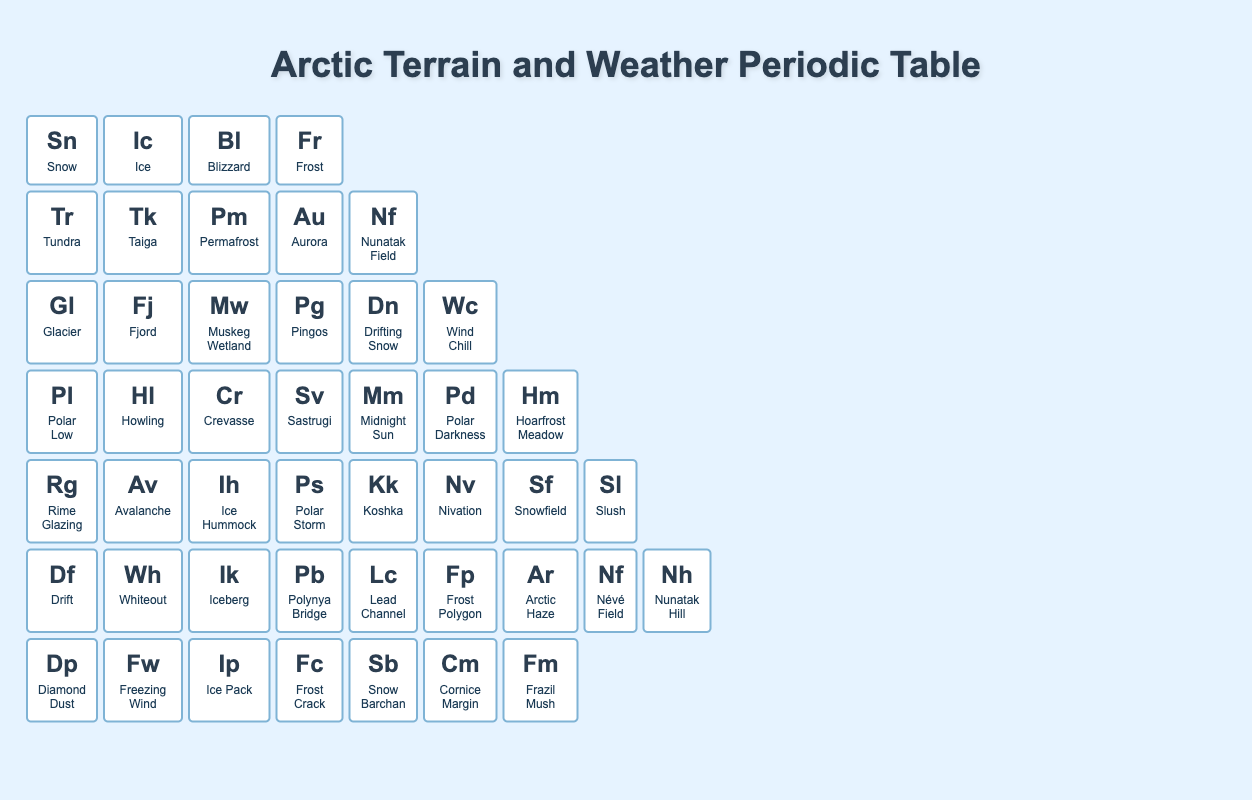What is the symbol for Tundra? The symbol for Tundra can be found by locating the element in the table; Tundra is listed under group 1 and period 2, and its symbol is Tr.
Answer: Tr How many elements are in period 3? To find the number of elements in period 3, count the entries listed in that row of the table; there are 6 elements: Glacier, Fjord, Muskeg Wetland, Pingos, Drifting Snow, and Wind Chill.
Answer: 6 Is Ice in group 2? By identifying the group of Ice in the table, we see it is listed under group 2. Therefore, the statement is true.
Answer: Yes Which element has the highest period number? The element with the highest period number is the last row of the table, which corresponds to period 7. The elements listed there are Diamond Dust, Freezing Wind, Ice Pack, Frost Crack, Snow Barchan, Cornice Margin, and Frazil Mush; hence, all of these belong to period 7.
Answer: Diamond Dust, Freezing Wind, Ice Pack, Frost Crack, Snow Barchan, Cornice Margin, Frazil Mush How many unique groups are represented in period 5? We can find the elements in period 5: Rime Glazing, Avalanche, Ice Hummock, Polar Storm, Koshka, Nivation, Snowfield, and Slush. Their groups are 1, 2, 3, 4, 5, 6, 7, and 8—a total of 8 unique groups are present.
Answer: 8 What is the total count of elements from group 3? Observe the elements listed in group 3 across all periods. The elements are Blizzard, Permafrost, Muskeg Wetland, Crevasse, Ice Hummock, and Ice Pack, resulting in a total count of 6 elements.
Answer: 6 Which element in period 6 shares group membership with Iceberg? Iceberg is located in period 6 under group 3; checking this row against the groups reveals that the element "Ik" is Iceberg and there are no other elements in group 3 for this period. Thus, Iceberg does not share its group value with any others.
Answer: None Are there more elements in group 1 compared to group 2 in period 4? Group 1 has Polar Low and group 2 has Howling in period 4. Group 1 has 1 element while group 2 also has 1 element; therefore, there aren't more in either group.
Answer: No 